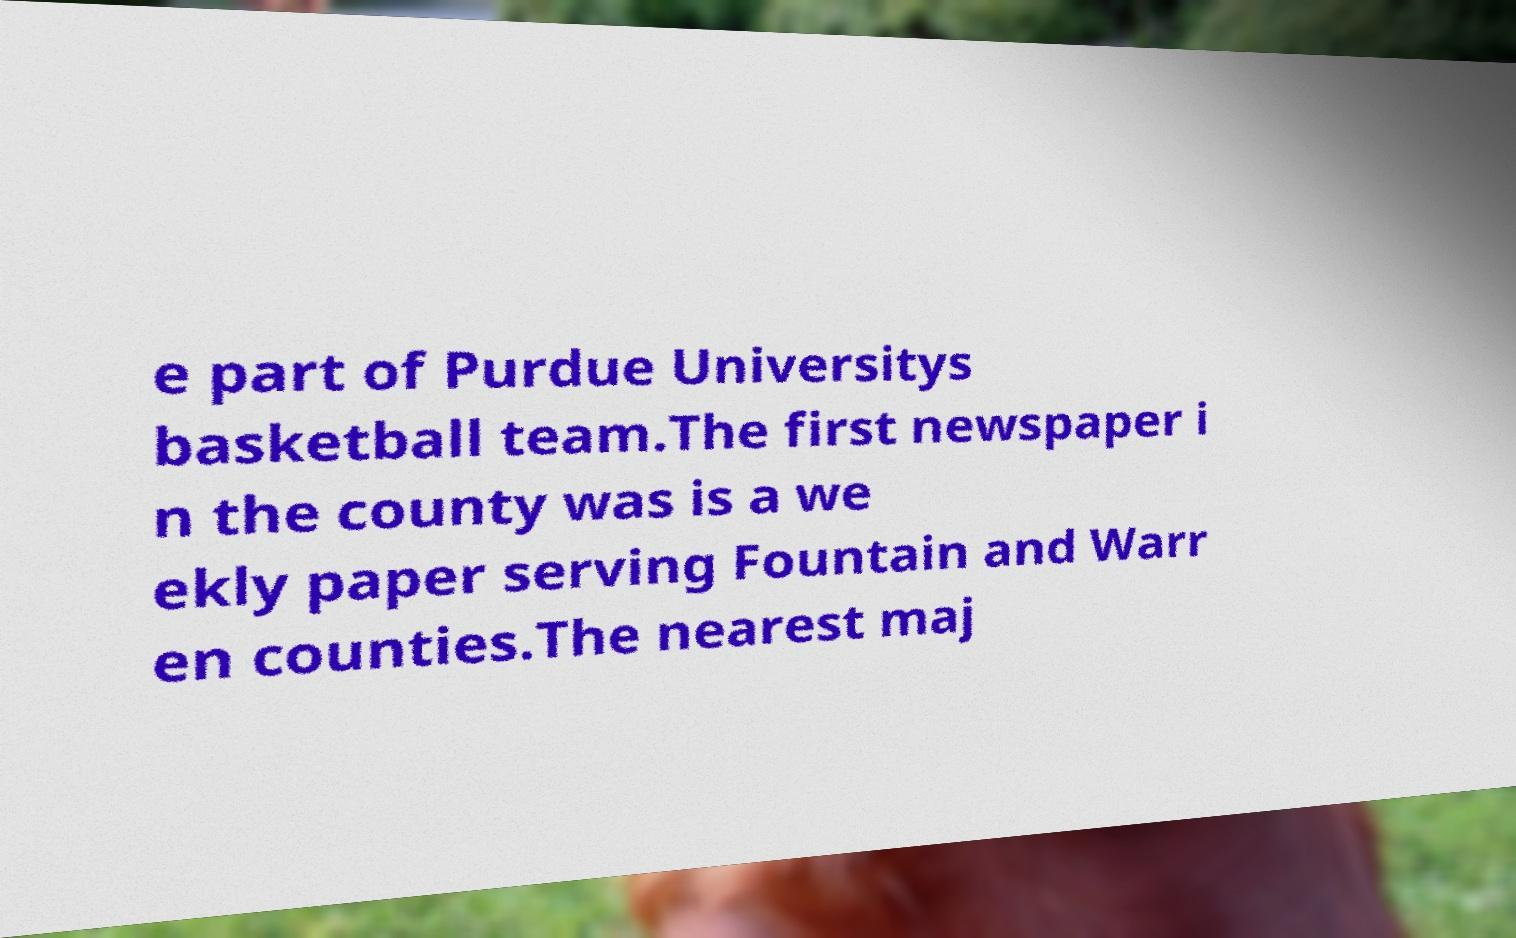Could you assist in decoding the text presented in this image and type it out clearly? e part of Purdue Universitys basketball team.The first newspaper i n the county was is a we ekly paper serving Fountain and Warr en counties.The nearest maj 